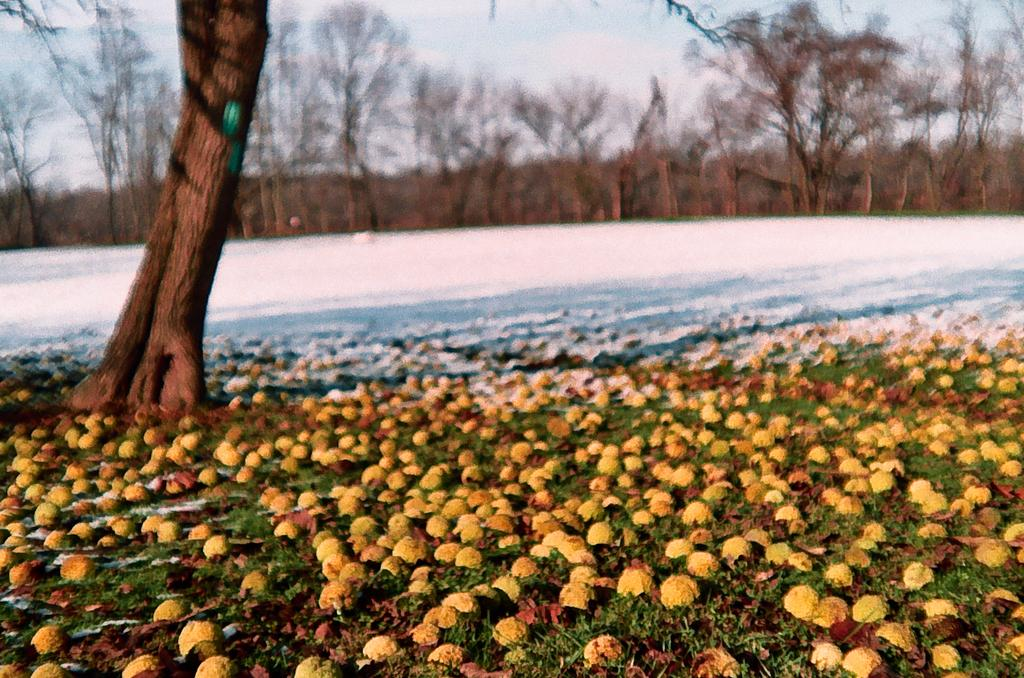What is on the ground in the image? There are fruits on the ground in the image. What is the weather like in the image? There is snow visible in the image, indicating a cold or wintery environment. What type of vegetation can be seen in the image? There are trees and plants in the image. What type of attraction is visible in the image? There is no attraction present in the image; it features fruits on the ground, snow, trees, and plants. What color is the flag in the image? There is no flag present in the image. 